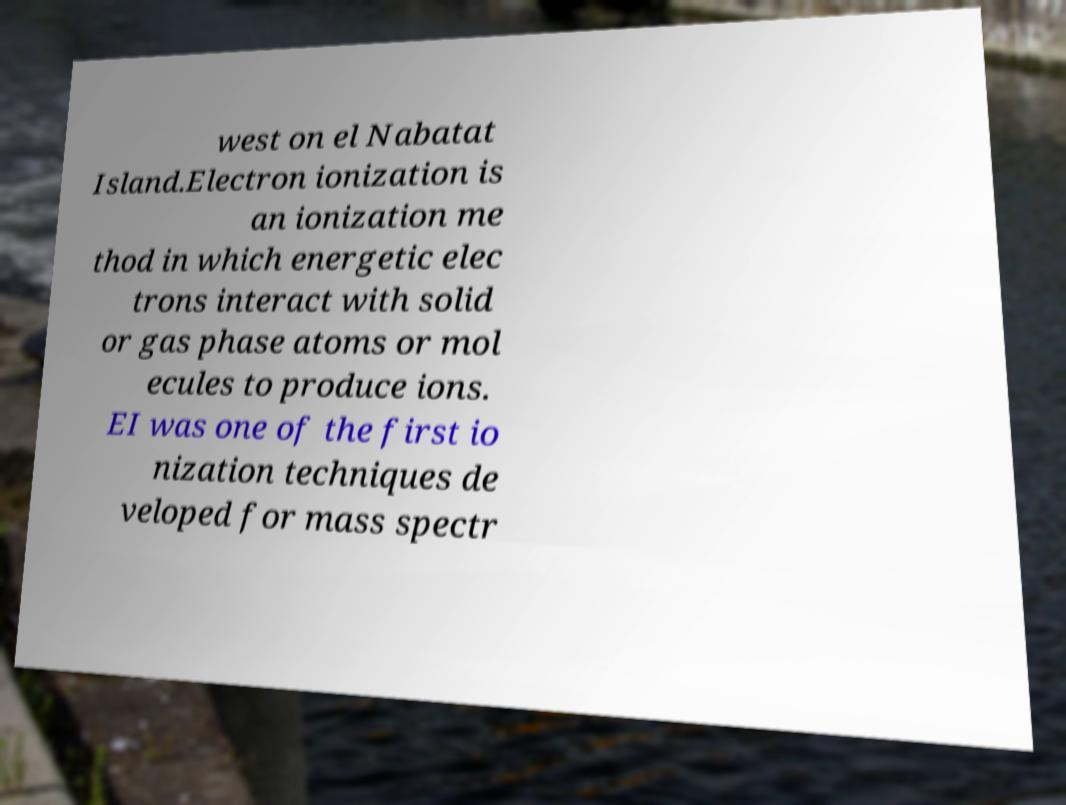There's text embedded in this image that I need extracted. Can you transcribe it verbatim? west on el Nabatat Island.Electron ionization is an ionization me thod in which energetic elec trons interact with solid or gas phase atoms or mol ecules to produce ions. EI was one of the first io nization techniques de veloped for mass spectr 